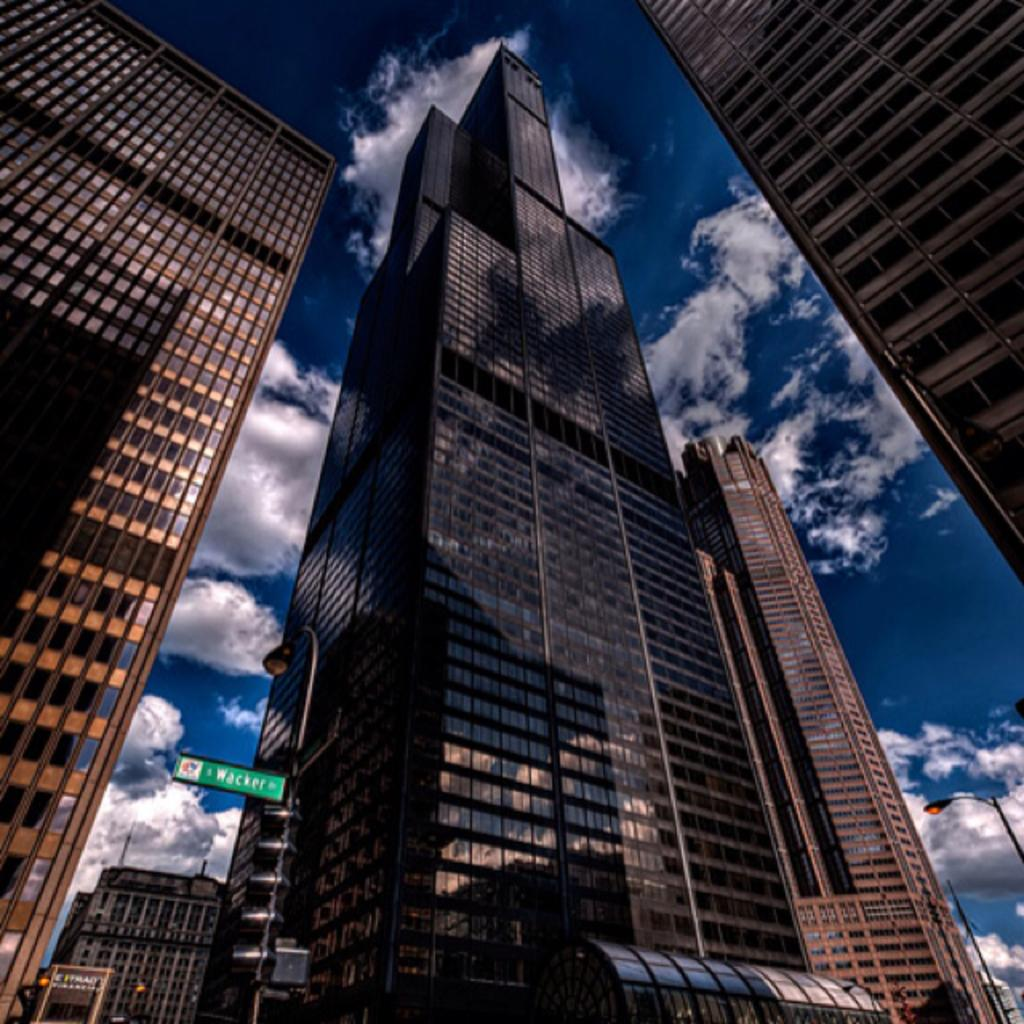What type of structures can be seen in the image? There are buildings in the image. What else can be seen in the image besides buildings? There are poles and boards visible in the image. What is visible in the background of the image? The sky is visible in the background of the image. What can be observed in the sky? Clouds are present in the sky. Where is the judge located in the image? There is no judge present in the image. What type of stocking can be seen hanging from the poles in the image? There are no stockings present in the image; only buildings, poles, boards, and clouds can be observed. 